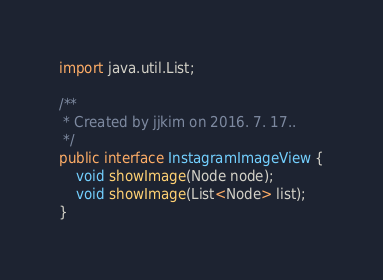Convert code to text. <code><loc_0><loc_0><loc_500><loc_500><_Java_>import java.util.List;

/**
 * Created by jjkim on 2016. 7. 17..
 */
public interface InstagramImageView {
    void showImage(Node node);
    void showImage(List<Node> list);
}
</code> 